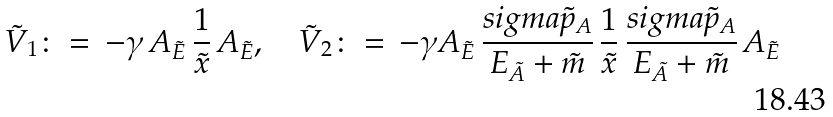<formula> <loc_0><loc_0><loc_500><loc_500>\tilde { V } _ { 1 } \colon = \, - \gamma \, A _ { \tilde { E } } \, \frac { 1 } { \tilde { x } } \, A _ { \tilde { E } } , \quad \tilde { V } _ { 2 } \colon = \, - \gamma A _ { \tilde { E } } \, \frac { s i g m a \tilde { p } _ { A } } { E _ { \tilde { A } } + \tilde { m } } \, \frac { 1 } { \tilde { x } } \, \frac { s i g m a \tilde { p } _ { A } } { E _ { \tilde { A } } + \tilde { m } } \, A _ { \tilde { E } }</formula> 